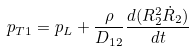<formula> <loc_0><loc_0><loc_500><loc_500>p _ { T 1 } = p _ { L } + \frac { \rho } { D _ { 1 2 } } \frac { d ( R _ { 2 } ^ { 2 } \dot { R } _ { 2 } ) } { d t }</formula> 